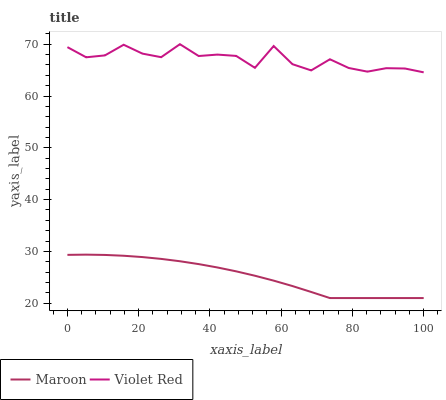Does Maroon have the minimum area under the curve?
Answer yes or no. Yes. Does Violet Red have the maximum area under the curve?
Answer yes or no. Yes. Does Maroon have the maximum area under the curve?
Answer yes or no. No. Is Maroon the smoothest?
Answer yes or no. Yes. Is Violet Red the roughest?
Answer yes or no. Yes. Is Maroon the roughest?
Answer yes or no. No. Does Maroon have the lowest value?
Answer yes or no. Yes. Does Violet Red have the highest value?
Answer yes or no. Yes. Does Maroon have the highest value?
Answer yes or no. No. Is Maroon less than Violet Red?
Answer yes or no. Yes. Is Violet Red greater than Maroon?
Answer yes or no. Yes. Does Maroon intersect Violet Red?
Answer yes or no. No. 